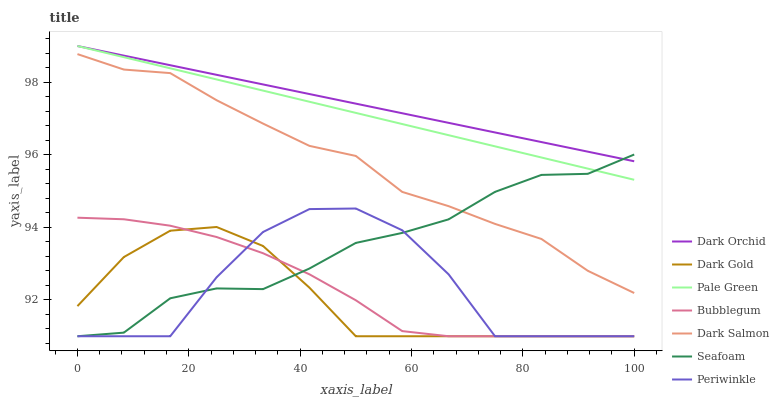Does Dark Gold have the minimum area under the curve?
Answer yes or no. Yes. Does Dark Orchid have the maximum area under the curve?
Answer yes or no. Yes. Does Seafoam have the minimum area under the curve?
Answer yes or no. No. Does Seafoam have the maximum area under the curve?
Answer yes or no. No. Is Dark Orchid the smoothest?
Answer yes or no. Yes. Is Periwinkle the roughest?
Answer yes or no. Yes. Is Seafoam the smoothest?
Answer yes or no. No. Is Seafoam the roughest?
Answer yes or no. No. Does Dark Gold have the lowest value?
Answer yes or no. Yes. Does Dark Salmon have the lowest value?
Answer yes or no. No. Does Dark Orchid have the highest value?
Answer yes or no. Yes. Does Seafoam have the highest value?
Answer yes or no. No. Is Bubblegum less than Dark Salmon?
Answer yes or no. Yes. Is Dark Orchid greater than Dark Salmon?
Answer yes or no. Yes. Does Seafoam intersect Periwinkle?
Answer yes or no. Yes. Is Seafoam less than Periwinkle?
Answer yes or no. No. Is Seafoam greater than Periwinkle?
Answer yes or no. No. Does Bubblegum intersect Dark Salmon?
Answer yes or no. No. 